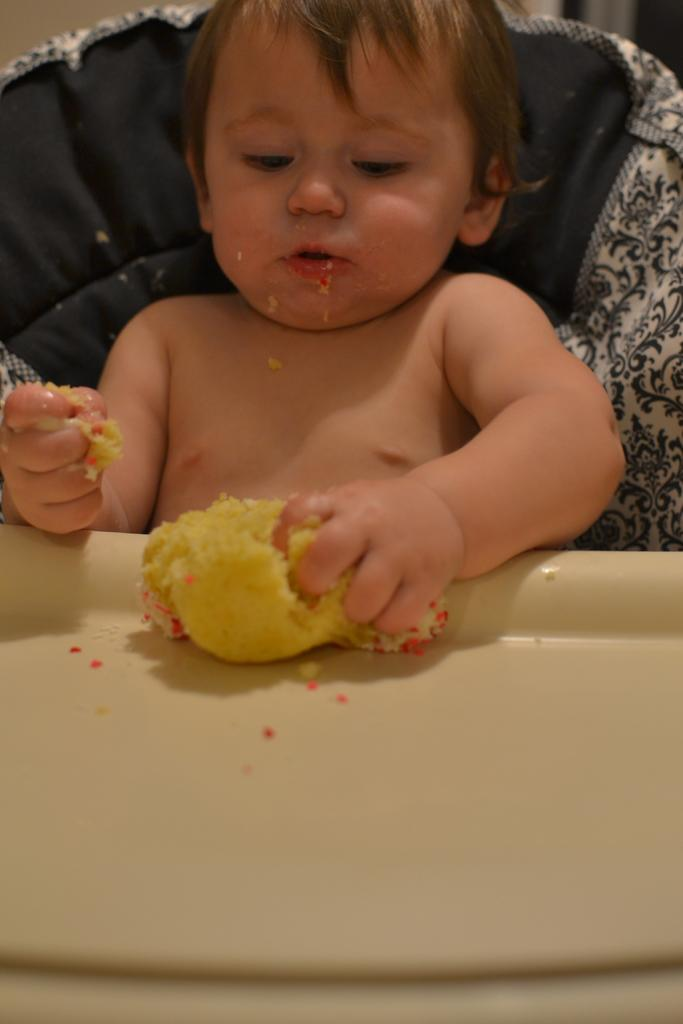What is the main subject of the image? There is a child in the image. What is the child doing in the image? The child is sitting. What is the child holding in their hand? The child is holding a food item in their hand. What type of fang can be seen in the image? There are no fangs present in the image; it features a child sitting and holding a food item. 